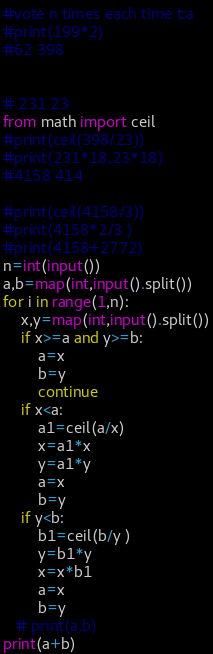Convert code to text. <code><loc_0><loc_0><loc_500><loc_500><_Python_>#vote n times each time t:a 
#print(199*2)
#62 398 


# 231 23  
from math import ceil 
#print(ceil(398/23))
#print(231*18,23*18)
#4158 414 

#print(ceil(4158/3))
#print(4158*2/3 )
#print(4158+2772)
n=int(input())
a,b=map(int,input().split())
for i in range(1,n):
    x,y=map(int,input().split())
    if x>=a and y>=b:
        a=x 
        b=y 
        continue 
    if x<a:
        a1=ceil(a/x)
        x=a1*x 
        y=a1*y 
        a=x 
        b=y 
    if y<b: 
        b1=ceil(b/y )
        y=b1*y  
        x=x*b1  
        a=x 
        b=y 
   # print(a,b)
print(a+b)</code> 